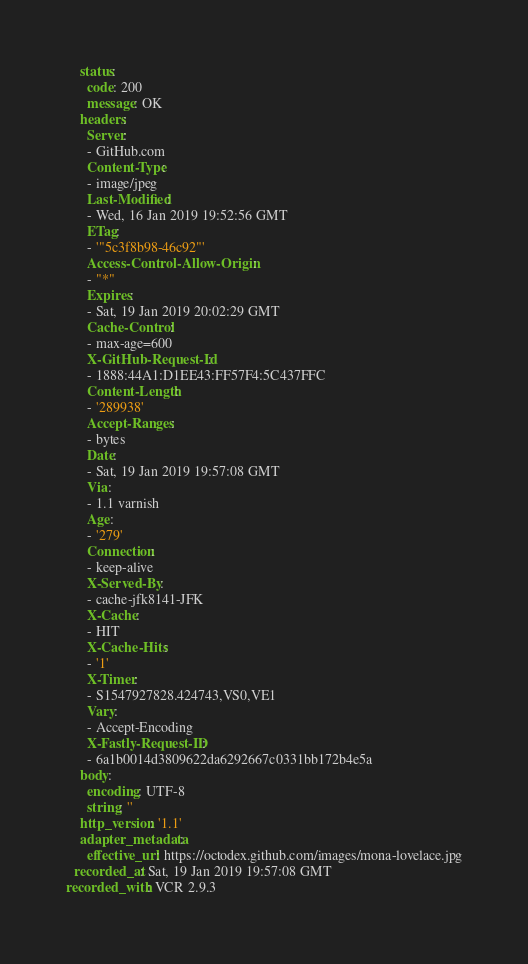<code> <loc_0><loc_0><loc_500><loc_500><_YAML_>    status:
      code: 200
      message: OK
    headers:
      Server:
      - GitHub.com
      Content-Type:
      - image/jpeg
      Last-Modified:
      - Wed, 16 Jan 2019 19:52:56 GMT
      ETag:
      - '"5c3f8b98-46c92"'
      Access-Control-Allow-Origin:
      - "*"
      Expires:
      - Sat, 19 Jan 2019 20:02:29 GMT
      Cache-Control:
      - max-age=600
      X-GitHub-Request-Id:
      - 1888:44A1:D1EE43:FF57F4:5C437FFC
      Content-Length:
      - '289938'
      Accept-Ranges:
      - bytes
      Date:
      - Sat, 19 Jan 2019 19:57:08 GMT
      Via:
      - 1.1 varnish
      Age:
      - '279'
      Connection:
      - keep-alive
      X-Served-By:
      - cache-jfk8141-JFK
      X-Cache:
      - HIT
      X-Cache-Hits:
      - '1'
      X-Timer:
      - S1547927828.424743,VS0,VE1
      Vary:
      - Accept-Encoding
      X-Fastly-Request-ID:
      - 6a1b0014d3809622da6292667c0331bb172b4e5a
    body:
      encoding: UTF-8
      string: ''
    http_version: '1.1'
    adapter_metadata:
      effective_url: https://octodex.github.com/images/mona-lovelace.jpg
  recorded_at: Sat, 19 Jan 2019 19:57:08 GMT
recorded_with: VCR 2.9.3
</code> 